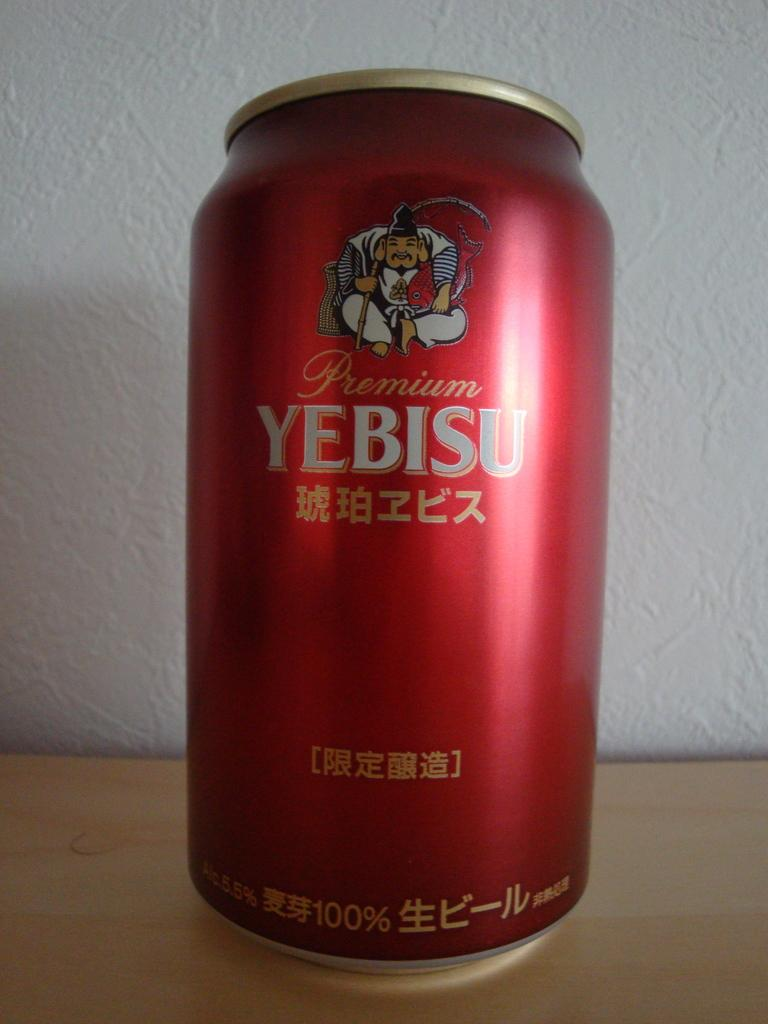<image>
Offer a succinct explanation of the picture presented. a can of soda with Yebisu on it 